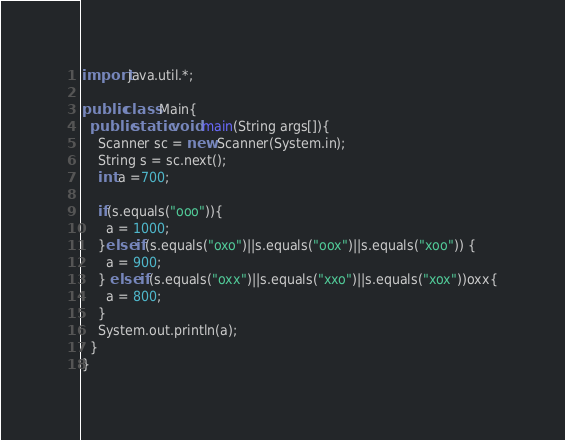<code> <loc_0><loc_0><loc_500><loc_500><_Java_>import java.util.*;

public class Main{
  public static void main(String args[]){
    Scanner sc = new Scanner(System.in);
    String s = sc.next();
    int a =700;
    
    if(s.equals("ooo")){
      a = 1000;
    }else if(s.equals("oxo")||s.equals("oox")||s.equals("xoo")) {
      a = 900;
    } else if(s.equals("oxx")||s.equals("xxo")||s.equals("xox"))oxx{
      a = 800;
    }
    System.out.println(a);
  }
}</code> 